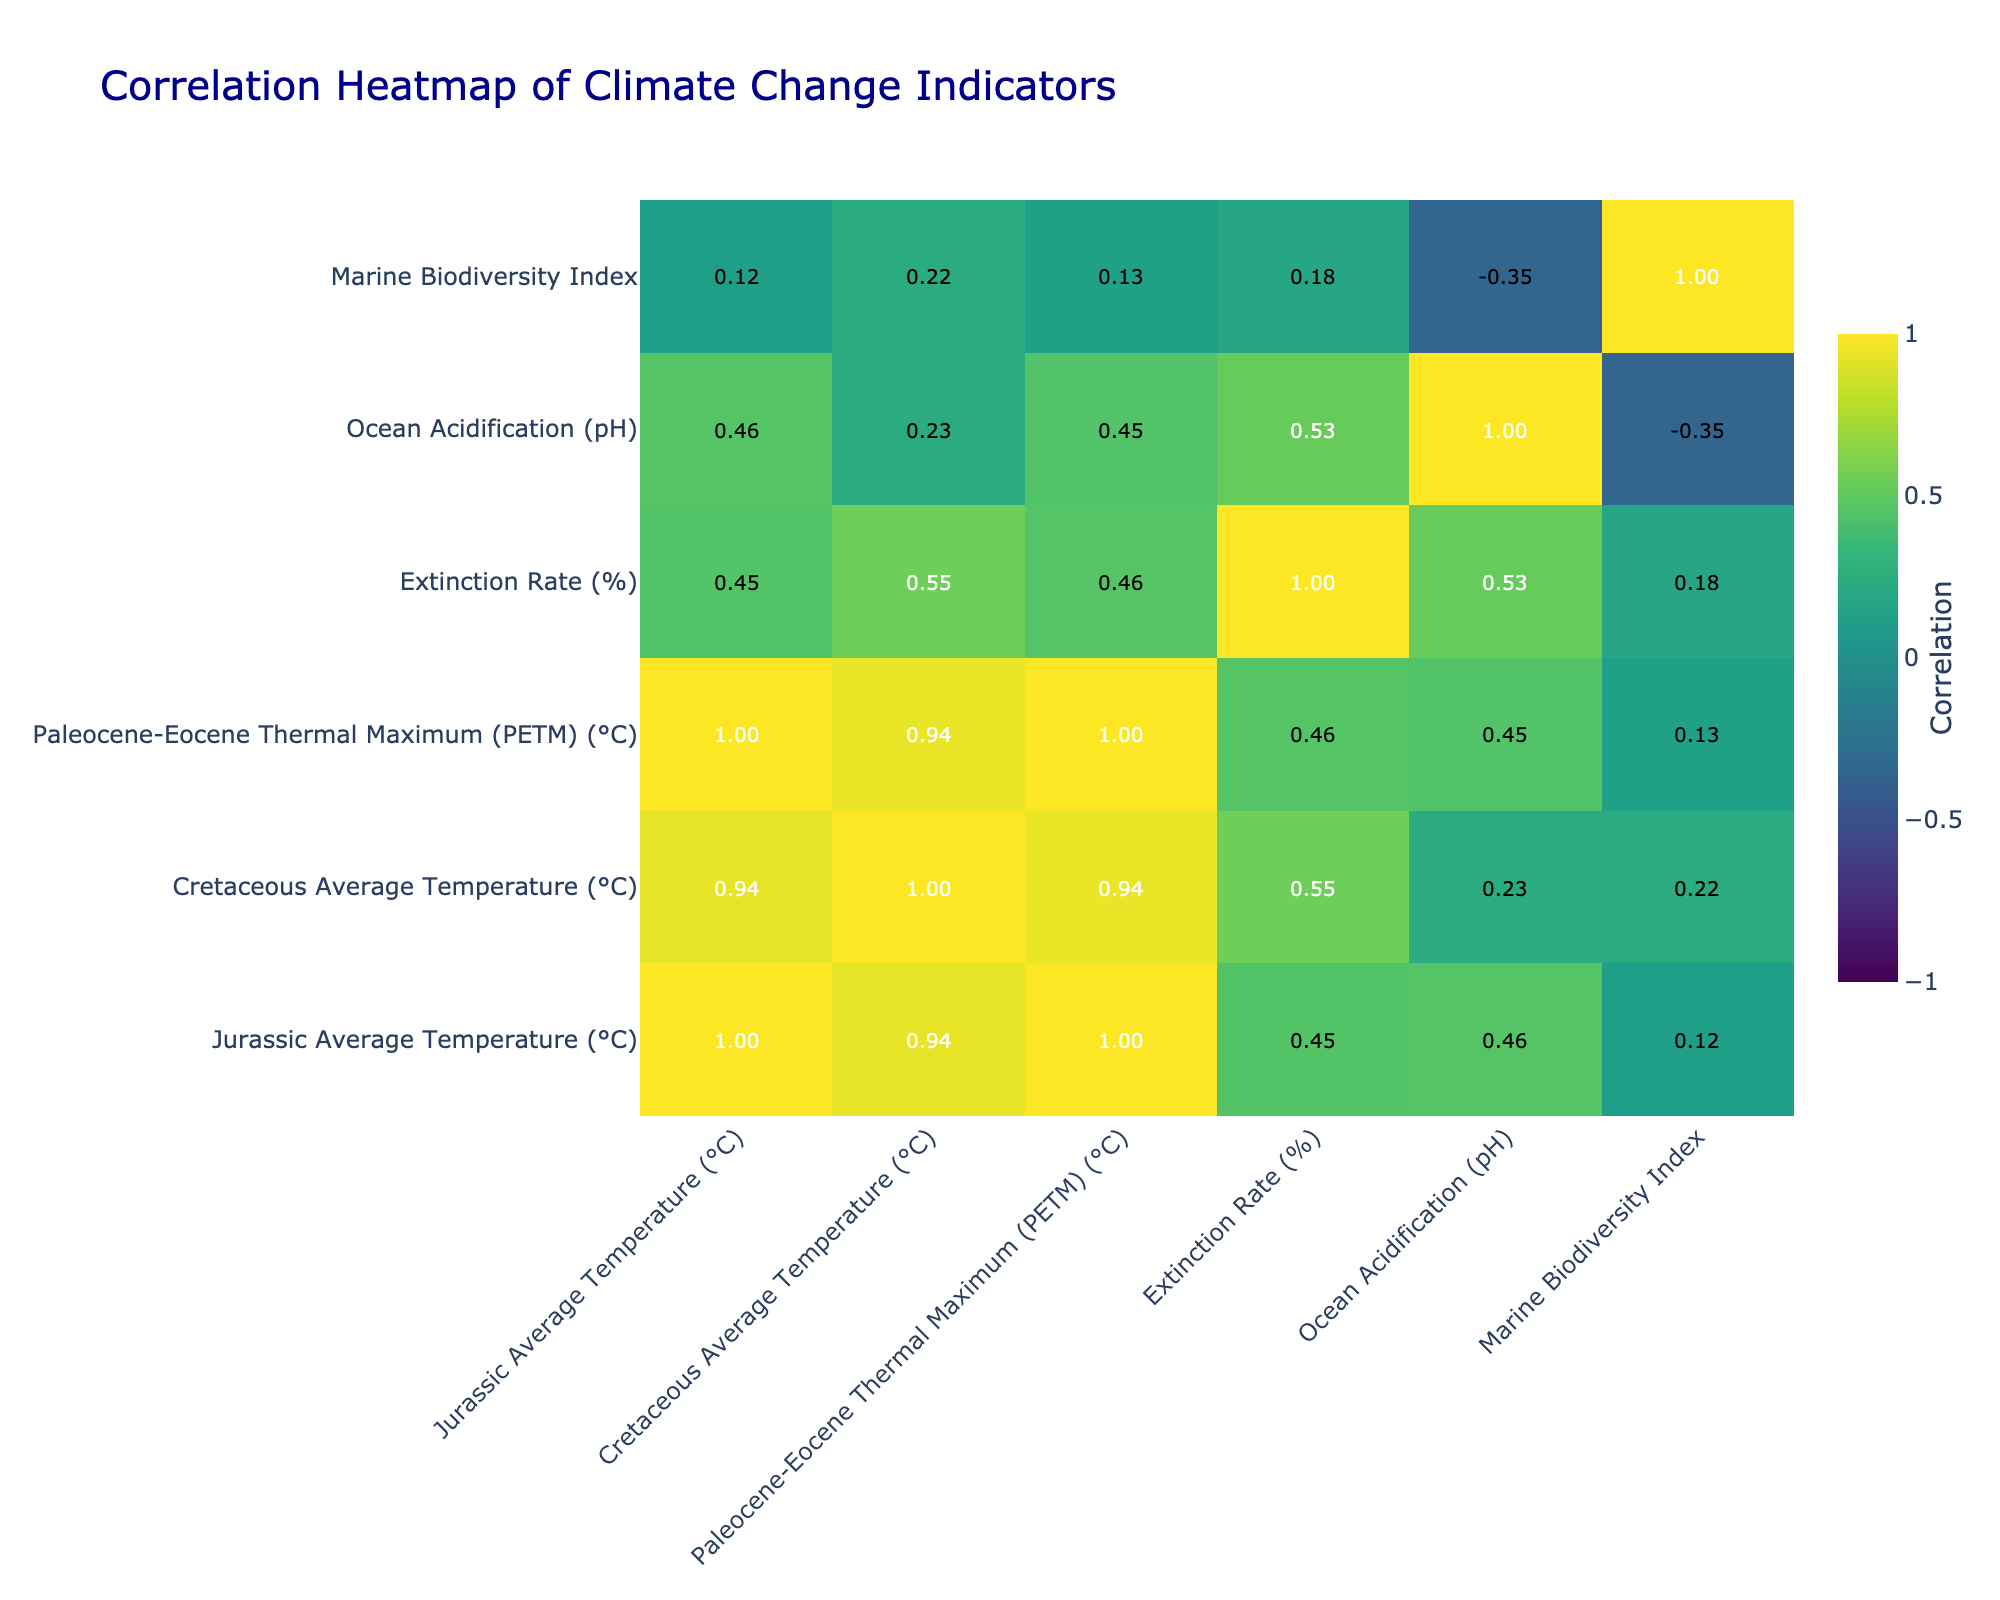What is the correlation between Carbon Dioxide Levels and Extinction Rate? The correlation value is indicated in the table. Looking at the row for Carbon Dioxide Levels and the column for Extinction Rate, it shows a correlation of 0.60.
Answer: 0.60 Which climate indicator has the lowest correlation with Marine Biodiversity Index? By examining the Marine Biodiversity Index row, the lowest correlation can be identified by comparing the values across the columns. The lowest value is 0.12, corresponding to Mass Extinction Events.
Answer: Mass Extinction Events What is the average correlation of Sea Level Rise with all other indicators? The correlation values for Sea Level Rise with other indicators are 1.00 for Jurassic Average Temperature, 0.33 for Cretaceous Average Temperature, 0.32 for PETM, 0.50 for Extinction Rate, 0.20 for Ocean Acidification, and 0.50 for Fossil Record Diversity Index. Adding these values (1.00 + 0.33 + 0.32 + 0.50 + 0.20 + 0.50) gives 2.85. Dividing by the number of indicators (6) yields an average correlation of 0.475.
Answer: 0.475 Is there a significant correlation (greater than 0.5) between the Ocean Temperature Anomaly and Extinction Rate? Examining the correlation between Ocean Temperature Anomaly and Extinction Rate as listed in the table, the correlation value is 0.55, which is greater than 0.5. Therefore, the statement is true.
Answer: Yes What is the difference between the correlation of Carbon Dioxide Levels with Jurassic Average Temperature and Cretaceous Average Temperature? Looking at the correlation values provided for Carbon Dioxide Levels, Jurassic Average Temperature has 0.80 and Cretaceous Average Temperature has 0.60. To find the difference, subtract the smaller value from the larger value: 0.80 - 0.60 = 0.20.
Answer: 0.20 